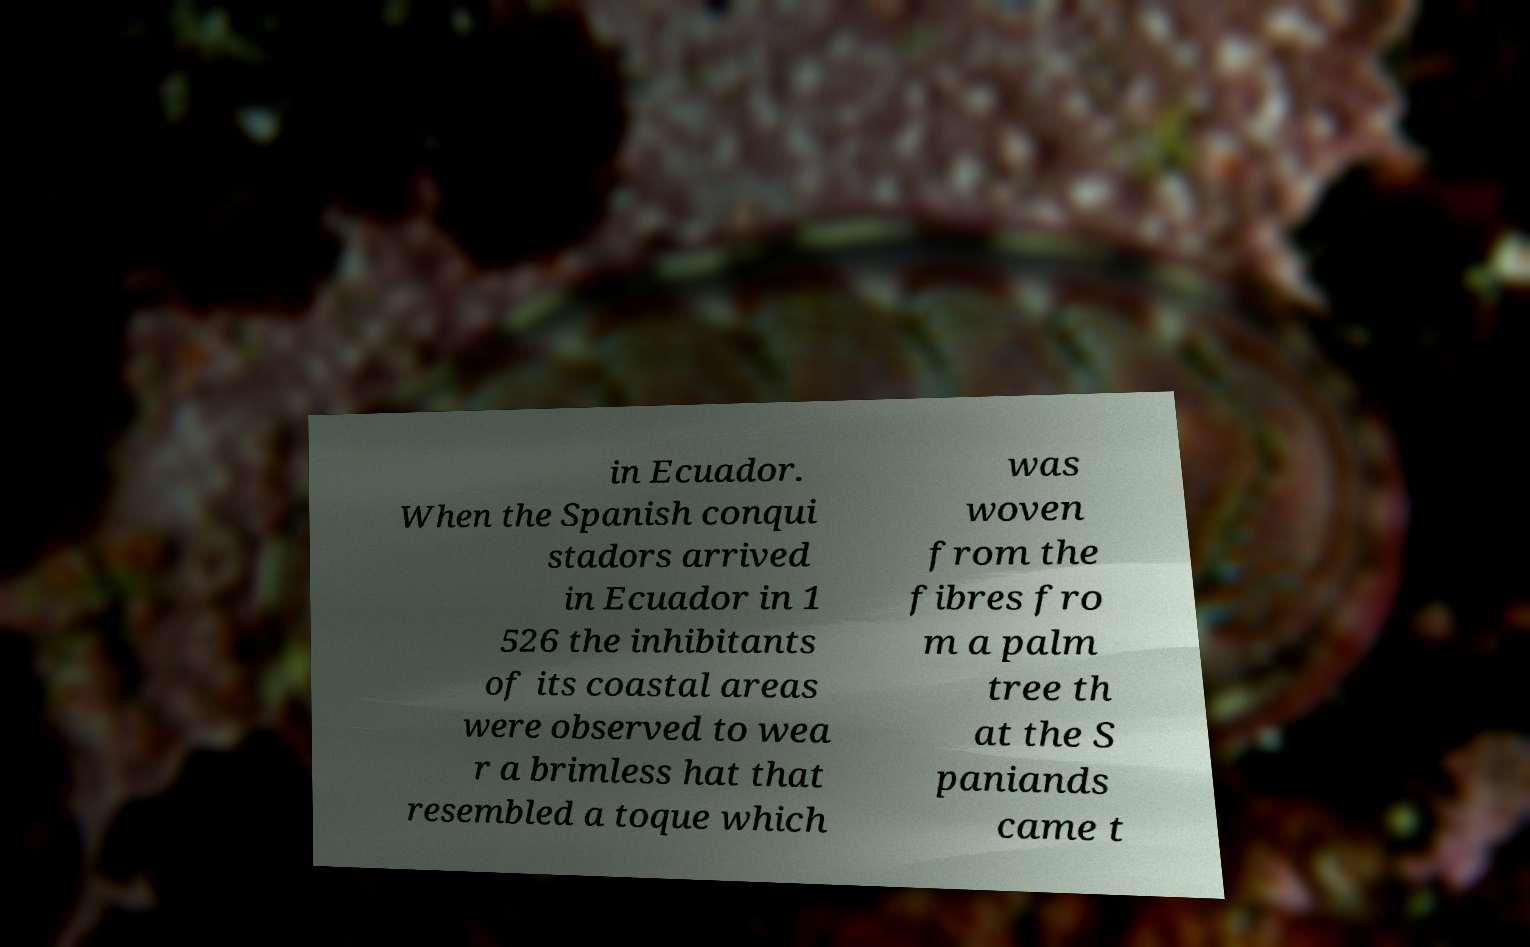Could you assist in decoding the text presented in this image and type it out clearly? in Ecuador. When the Spanish conqui stadors arrived in Ecuador in 1 526 the inhibitants of its coastal areas were observed to wea r a brimless hat that resembled a toque which was woven from the fibres fro m a palm tree th at the S paniands came t 